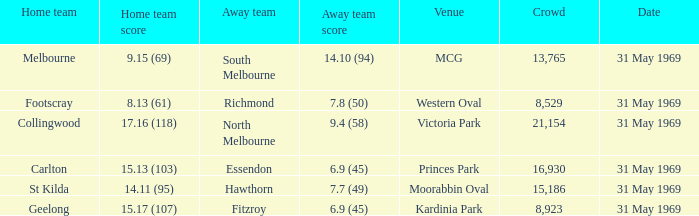Give me the full table as a dictionary. {'header': ['Home team', 'Home team score', 'Away team', 'Away team score', 'Venue', 'Crowd', 'Date'], 'rows': [['Melbourne', '9.15 (69)', 'South Melbourne', '14.10 (94)', 'MCG', '13,765', '31 May 1969'], ['Footscray', '8.13 (61)', 'Richmond', '7.8 (50)', 'Western Oval', '8,529', '31 May 1969'], ['Collingwood', '17.16 (118)', 'North Melbourne', '9.4 (58)', 'Victoria Park', '21,154', '31 May 1969'], ['Carlton', '15.13 (103)', 'Essendon', '6.9 (45)', 'Princes Park', '16,930', '31 May 1969'], ['St Kilda', '14.11 (95)', 'Hawthorn', '7.7 (49)', 'Moorabbin Oval', '15,186', '31 May 1969'], ['Geelong', '15.17 (107)', 'Fitzroy', '6.9 (45)', 'Kardinia Park', '8,923', '31 May 1969']]} Which home side scored 1 St Kilda. 